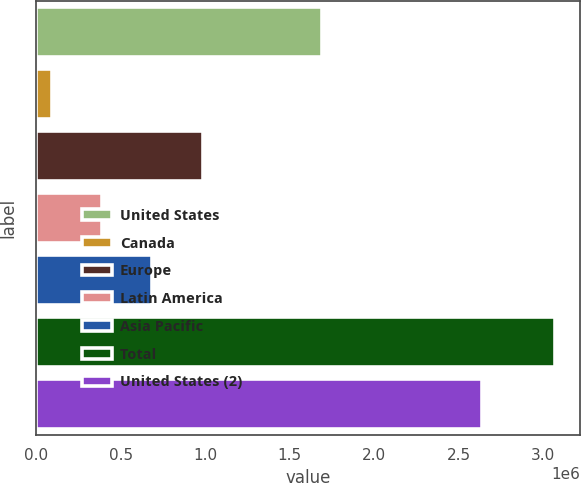Convert chart. <chart><loc_0><loc_0><loc_500><loc_500><bar_chart><fcel>United States<fcel>Canada<fcel>Europe<fcel>Latin America<fcel>Asia Pacific<fcel>Total<fcel>United States (2)<nl><fcel>1.68947e+06<fcel>92559<fcel>985106<fcel>390074<fcel>687590<fcel>3.06771e+06<fcel>2.63593e+06<nl></chart> 